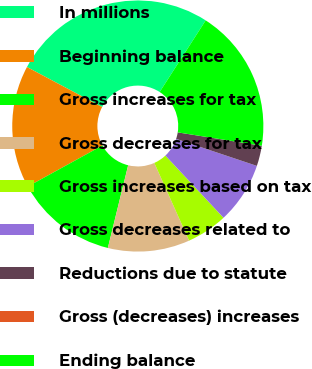Convert chart. <chart><loc_0><loc_0><loc_500><loc_500><pie_chart><fcel>In millions<fcel>Beginning balance<fcel>Gross increases for tax<fcel>Gross decreases for tax<fcel>Gross increases based on tax<fcel>Gross decreases related to<fcel>Reductions due to statute<fcel>Gross (decreases) increases<fcel>Ending balance<nl><fcel>26.31%<fcel>15.79%<fcel>13.16%<fcel>10.53%<fcel>5.26%<fcel>7.9%<fcel>2.63%<fcel>0.0%<fcel>18.42%<nl></chart> 